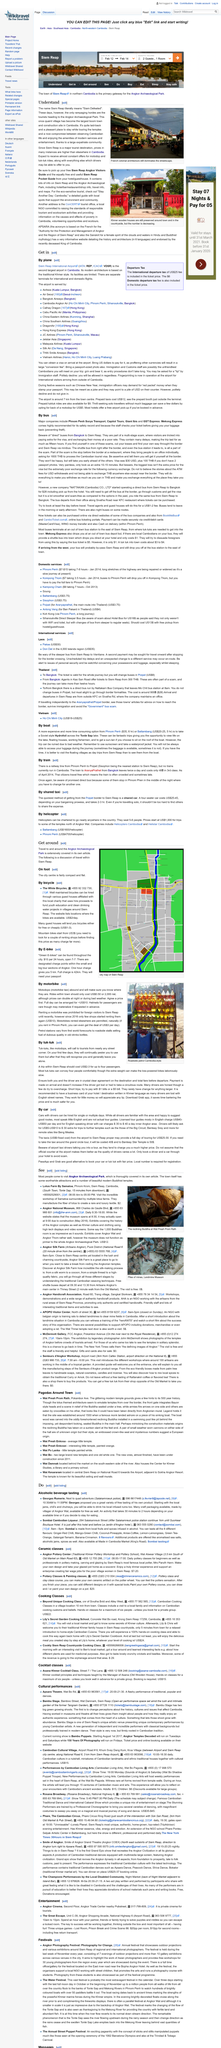Indicate a few pertinent items in this graphic. The bus journey that requires a change of buses in Poipet is traveling in Thailand. The name Siem Reap is derived from "Siam Defeated," which reflects the historical victory of the Khmer Empire over the Thai kingdom of Siam. The Nattakarn Bus Company departs from Mo Chit bus station to various locations where its buses travel. The Nattakarn Bus Company's bus fare is approximately 900฿ ($28). As a rider, I am interested in knowing the various rides that drivers can offer me. Specifically, I am interested in motodop and tuk-tuk rides. 